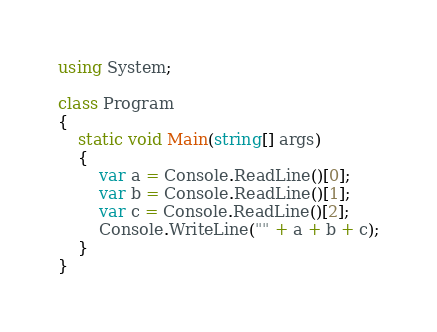<code> <loc_0><loc_0><loc_500><loc_500><_C#_>using System;

class Program
{
    static void Main(string[] args)
    {
        var a = Console.ReadLine()[0];
        var b = Console.ReadLine()[1];
        var c = Console.ReadLine()[2];
        Console.WriteLine("" + a + b + c);
    }
}
</code> 